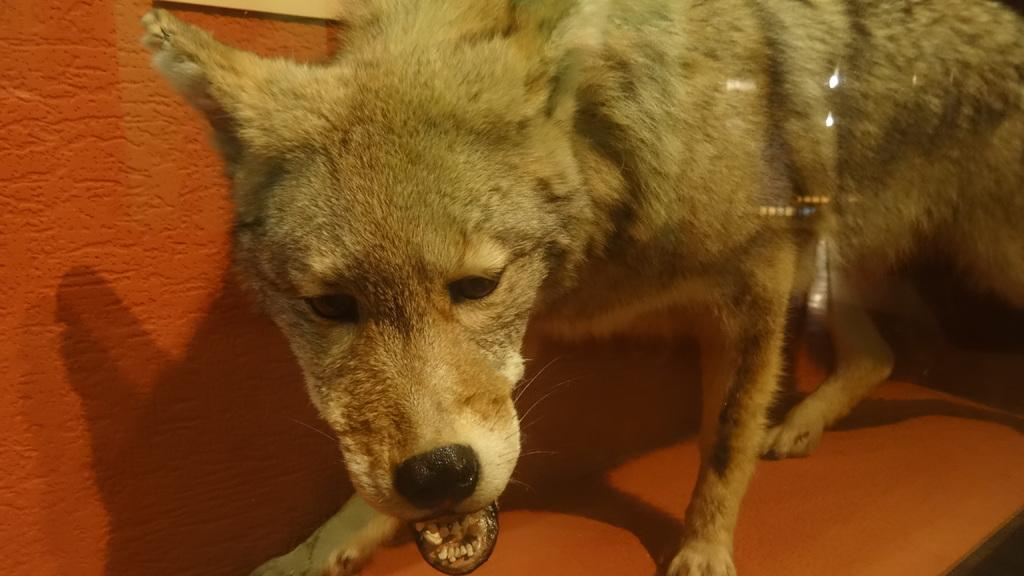What color is the wall in the image? There is an orange color wall in the image. What piece of furniture is present in the image? There is a table in the image. What animal can be seen on the table? There is a dog on the table. How many cows are present in the image? There are no cows present in the image; it features a dog on a table. What type of pocket can be seen in the image? There is no pocket present in the image. 